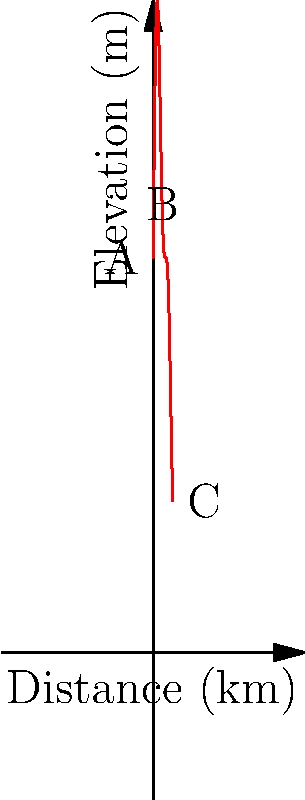The graph above shows the elevation profile of the popular "Sentier des Écorces" hiking trail near Lac-des-Écorces. If a hiker starts at point A and ends at point C, what is the total elevation gain experienced during the hike? To calculate the total elevation gain, we need to follow these steps:

1. Identify all the local maxima (peaks) in the elevation profile.
2. For each peak, calculate the elevation gain from the previous low point.
3. Sum up all these individual elevation gains.

From the graph, we can see:
- The hike starts at point A (elevation approximately 200m)
- There are two main peaks in the profile
- The hike ends at point C (elevation approximately 300m)

Let's calculate:
1. First peak (around 2.5km):
   - Starting elevation: 200m
   - Peak elevation: approximately 350m
   - Elevation gain: 350m - 200m = 150m

2. Second peak (around 7.5km):
   - Previous low point: approximately 250m
   - Peak elevation: approximately 375m
   - Elevation gain: 375m - 250m = 125m

3. Final ascent to point C:
   - Previous low point: approximately 225m
   - Ending elevation: 300m
   - Elevation gain: 300m - 225m = 75m

Total elevation gain = 150m + 125m + 75m = 350m

Therefore, the total elevation gain experienced during the hike is approximately 350 meters.
Answer: 350 meters 